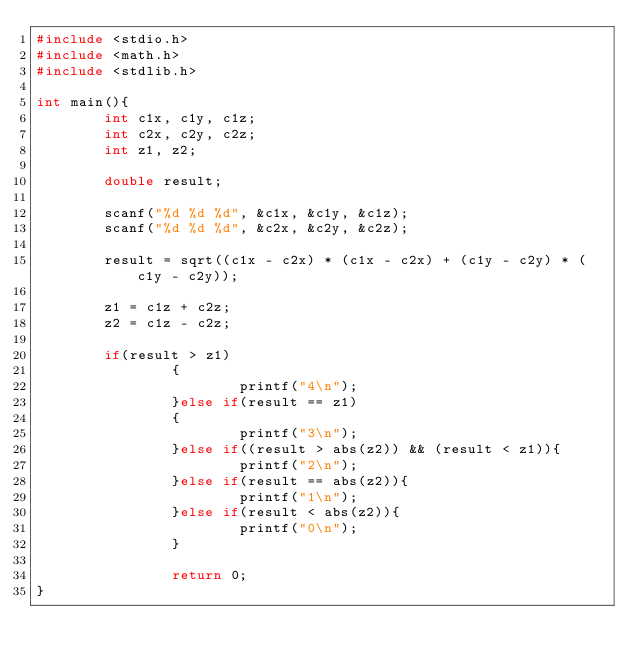Convert code to text. <code><loc_0><loc_0><loc_500><loc_500><_C_>#include <stdio.h>
#include <math.h>
#include <stdlib.h>

int main(){
        int c1x, c1y, c1z;
        int c2x, c2y, c2z;
        int z1, z2;

        double result;

        scanf("%d %d %d", &c1x, &c1y, &c1z);
        scanf("%d %d %d", &c2x, &c2y, &c2z);

        result = sqrt((c1x - c2x) * (c1x - c2x) + (c1y - c2y) * (c1y - c2y));

        z1 = c1z + c2z;
        z2 = c1z - c2z;

        if(result > z1)
                {
                        printf("4\n");
                }else if(result == z1)
                {
                        printf("3\n");
                }else if((result > abs(z2)) && (result < z1)){
                        printf("2\n");
                }else if(result == abs(z2)){
                        printf("1\n");
                }else if(result < abs(z2)){
                        printf("0\n");
                }

                return 0;
}
</code> 